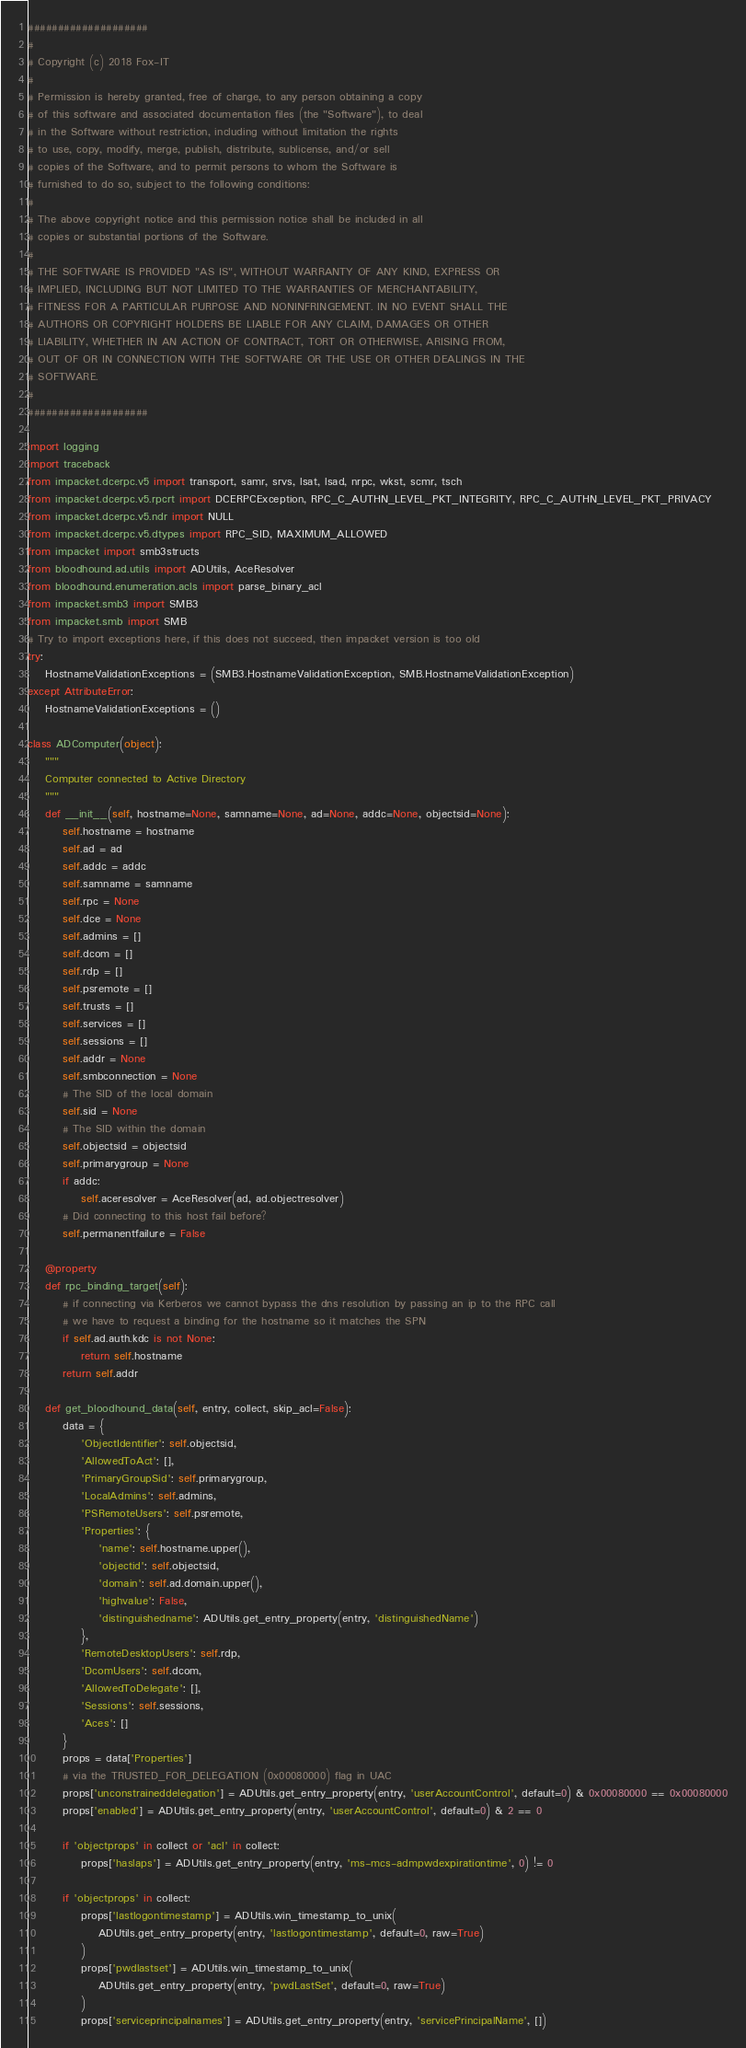Convert code to text. <code><loc_0><loc_0><loc_500><loc_500><_Python_>####################
#
# Copyright (c) 2018 Fox-IT
#
# Permission is hereby granted, free of charge, to any person obtaining a copy
# of this software and associated documentation files (the "Software"), to deal
# in the Software without restriction, including without limitation the rights
# to use, copy, modify, merge, publish, distribute, sublicense, and/or sell
# copies of the Software, and to permit persons to whom the Software is
# furnished to do so, subject to the following conditions:
#
# The above copyright notice and this permission notice shall be included in all
# copies or substantial portions of the Software.
#
# THE SOFTWARE IS PROVIDED "AS IS", WITHOUT WARRANTY OF ANY KIND, EXPRESS OR
# IMPLIED, INCLUDING BUT NOT LIMITED TO THE WARRANTIES OF MERCHANTABILITY,
# FITNESS FOR A PARTICULAR PURPOSE AND NONINFRINGEMENT. IN NO EVENT SHALL THE
# AUTHORS OR COPYRIGHT HOLDERS BE LIABLE FOR ANY CLAIM, DAMAGES OR OTHER
# LIABILITY, WHETHER IN AN ACTION OF CONTRACT, TORT OR OTHERWISE, ARISING FROM,
# OUT OF OR IN CONNECTION WITH THE SOFTWARE OR THE USE OR OTHER DEALINGS IN THE
# SOFTWARE.
#
####################

import logging
import traceback
from impacket.dcerpc.v5 import transport, samr, srvs, lsat, lsad, nrpc, wkst, scmr, tsch
from impacket.dcerpc.v5.rpcrt import DCERPCException, RPC_C_AUTHN_LEVEL_PKT_INTEGRITY, RPC_C_AUTHN_LEVEL_PKT_PRIVACY
from impacket.dcerpc.v5.ndr import NULL
from impacket.dcerpc.v5.dtypes import RPC_SID, MAXIMUM_ALLOWED
from impacket import smb3structs
from bloodhound.ad.utils import ADUtils, AceResolver
from bloodhound.enumeration.acls import parse_binary_acl
from impacket.smb3 import SMB3
from impacket.smb import SMB
# Try to import exceptions here, if this does not succeed, then impacket version is too old
try:
    HostnameValidationExceptions = (SMB3.HostnameValidationException, SMB.HostnameValidationException)
except AttributeError:
    HostnameValidationExceptions = ()

class ADComputer(object):
    """
    Computer connected to Active Directory
    """
    def __init__(self, hostname=None, samname=None, ad=None, addc=None, objectsid=None):
        self.hostname = hostname
        self.ad = ad
        self.addc = addc
        self.samname = samname
        self.rpc = None
        self.dce = None
        self.admins = []
        self.dcom = []
        self.rdp = []
        self.psremote = []
        self.trusts = []
        self.services = []
        self.sessions = []
        self.addr = None
        self.smbconnection = None
        # The SID of the local domain
        self.sid = None
        # The SID within the domain
        self.objectsid = objectsid
        self.primarygroup = None
        if addc:
            self.aceresolver = AceResolver(ad, ad.objectresolver)
        # Did connecting to this host fail before?
        self.permanentfailure = False

    @property
    def rpc_binding_target(self):
        # if connecting via Kerberos we cannot bypass the dns resolution by passing an ip to the RPC call 
        # we have to request a binding for the hostname so it matches the SPN
        if self.ad.auth.kdc is not None:
            return self.hostname 
        return self.addr

    def get_bloodhound_data(self, entry, collect, skip_acl=False):
        data = {
            'ObjectIdentifier': self.objectsid,
            'AllowedToAct': [],
            'PrimaryGroupSid': self.primarygroup,
            'LocalAdmins': self.admins,
            'PSRemoteUsers': self.psremote,
            'Properties': {
                'name': self.hostname.upper(),
                'objectid': self.objectsid,
                'domain': self.ad.domain.upper(),
                'highvalue': False,
                'distinguishedname': ADUtils.get_entry_property(entry, 'distinguishedName')
            },
            'RemoteDesktopUsers': self.rdp,
            'DcomUsers': self.dcom,
            'AllowedToDelegate': [],
            'Sessions': self.sessions,
            'Aces': []
        }
        props = data['Properties']
        # via the TRUSTED_FOR_DELEGATION (0x00080000) flag in UAC
        props['unconstraineddelegation'] = ADUtils.get_entry_property(entry, 'userAccountControl', default=0) & 0x00080000 == 0x00080000
        props['enabled'] = ADUtils.get_entry_property(entry, 'userAccountControl', default=0) & 2 == 0

        if 'objectprops' in collect or 'acl' in collect:
            props['haslaps'] = ADUtils.get_entry_property(entry, 'ms-mcs-admpwdexpirationtime', 0) != 0

        if 'objectprops' in collect:
            props['lastlogontimestamp'] = ADUtils.win_timestamp_to_unix(
                ADUtils.get_entry_property(entry, 'lastlogontimestamp', default=0, raw=True)
            )
            props['pwdlastset'] = ADUtils.win_timestamp_to_unix(
                ADUtils.get_entry_property(entry, 'pwdLastSet', default=0, raw=True)
            )
            props['serviceprincipalnames'] = ADUtils.get_entry_property(entry, 'servicePrincipalName', [])</code> 